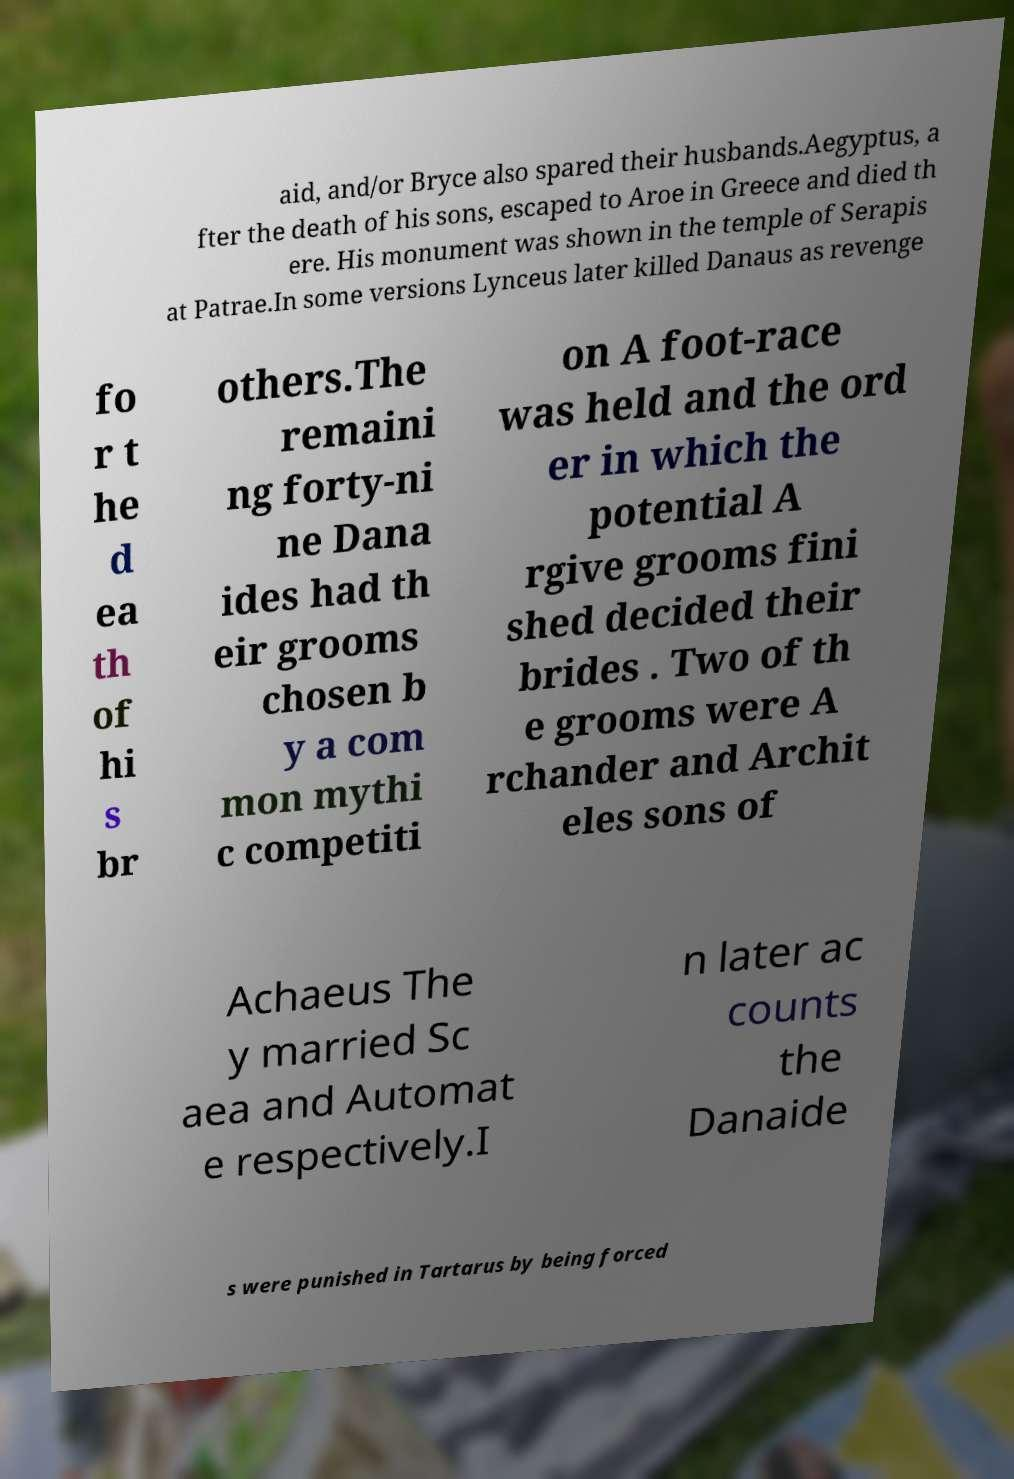Could you assist in decoding the text presented in this image and type it out clearly? aid, and/or Bryce also spared their husbands.Aegyptus, a fter the death of his sons, escaped to Aroe in Greece and died th ere. His monument was shown in the temple of Serapis at Patrae.In some versions Lynceus later killed Danaus as revenge fo r t he d ea th of hi s br others.The remaini ng forty-ni ne Dana ides had th eir grooms chosen b y a com mon mythi c competiti on A foot-race was held and the ord er in which the potential A rgive grooms fini shed decided their brides . Two of th e grooms were A rchander and Archit eles sons of Achaeus The y married Sc aea and Automat e respectively.I n later ac counts the Danaide s were punished in Tartarus by being forced 